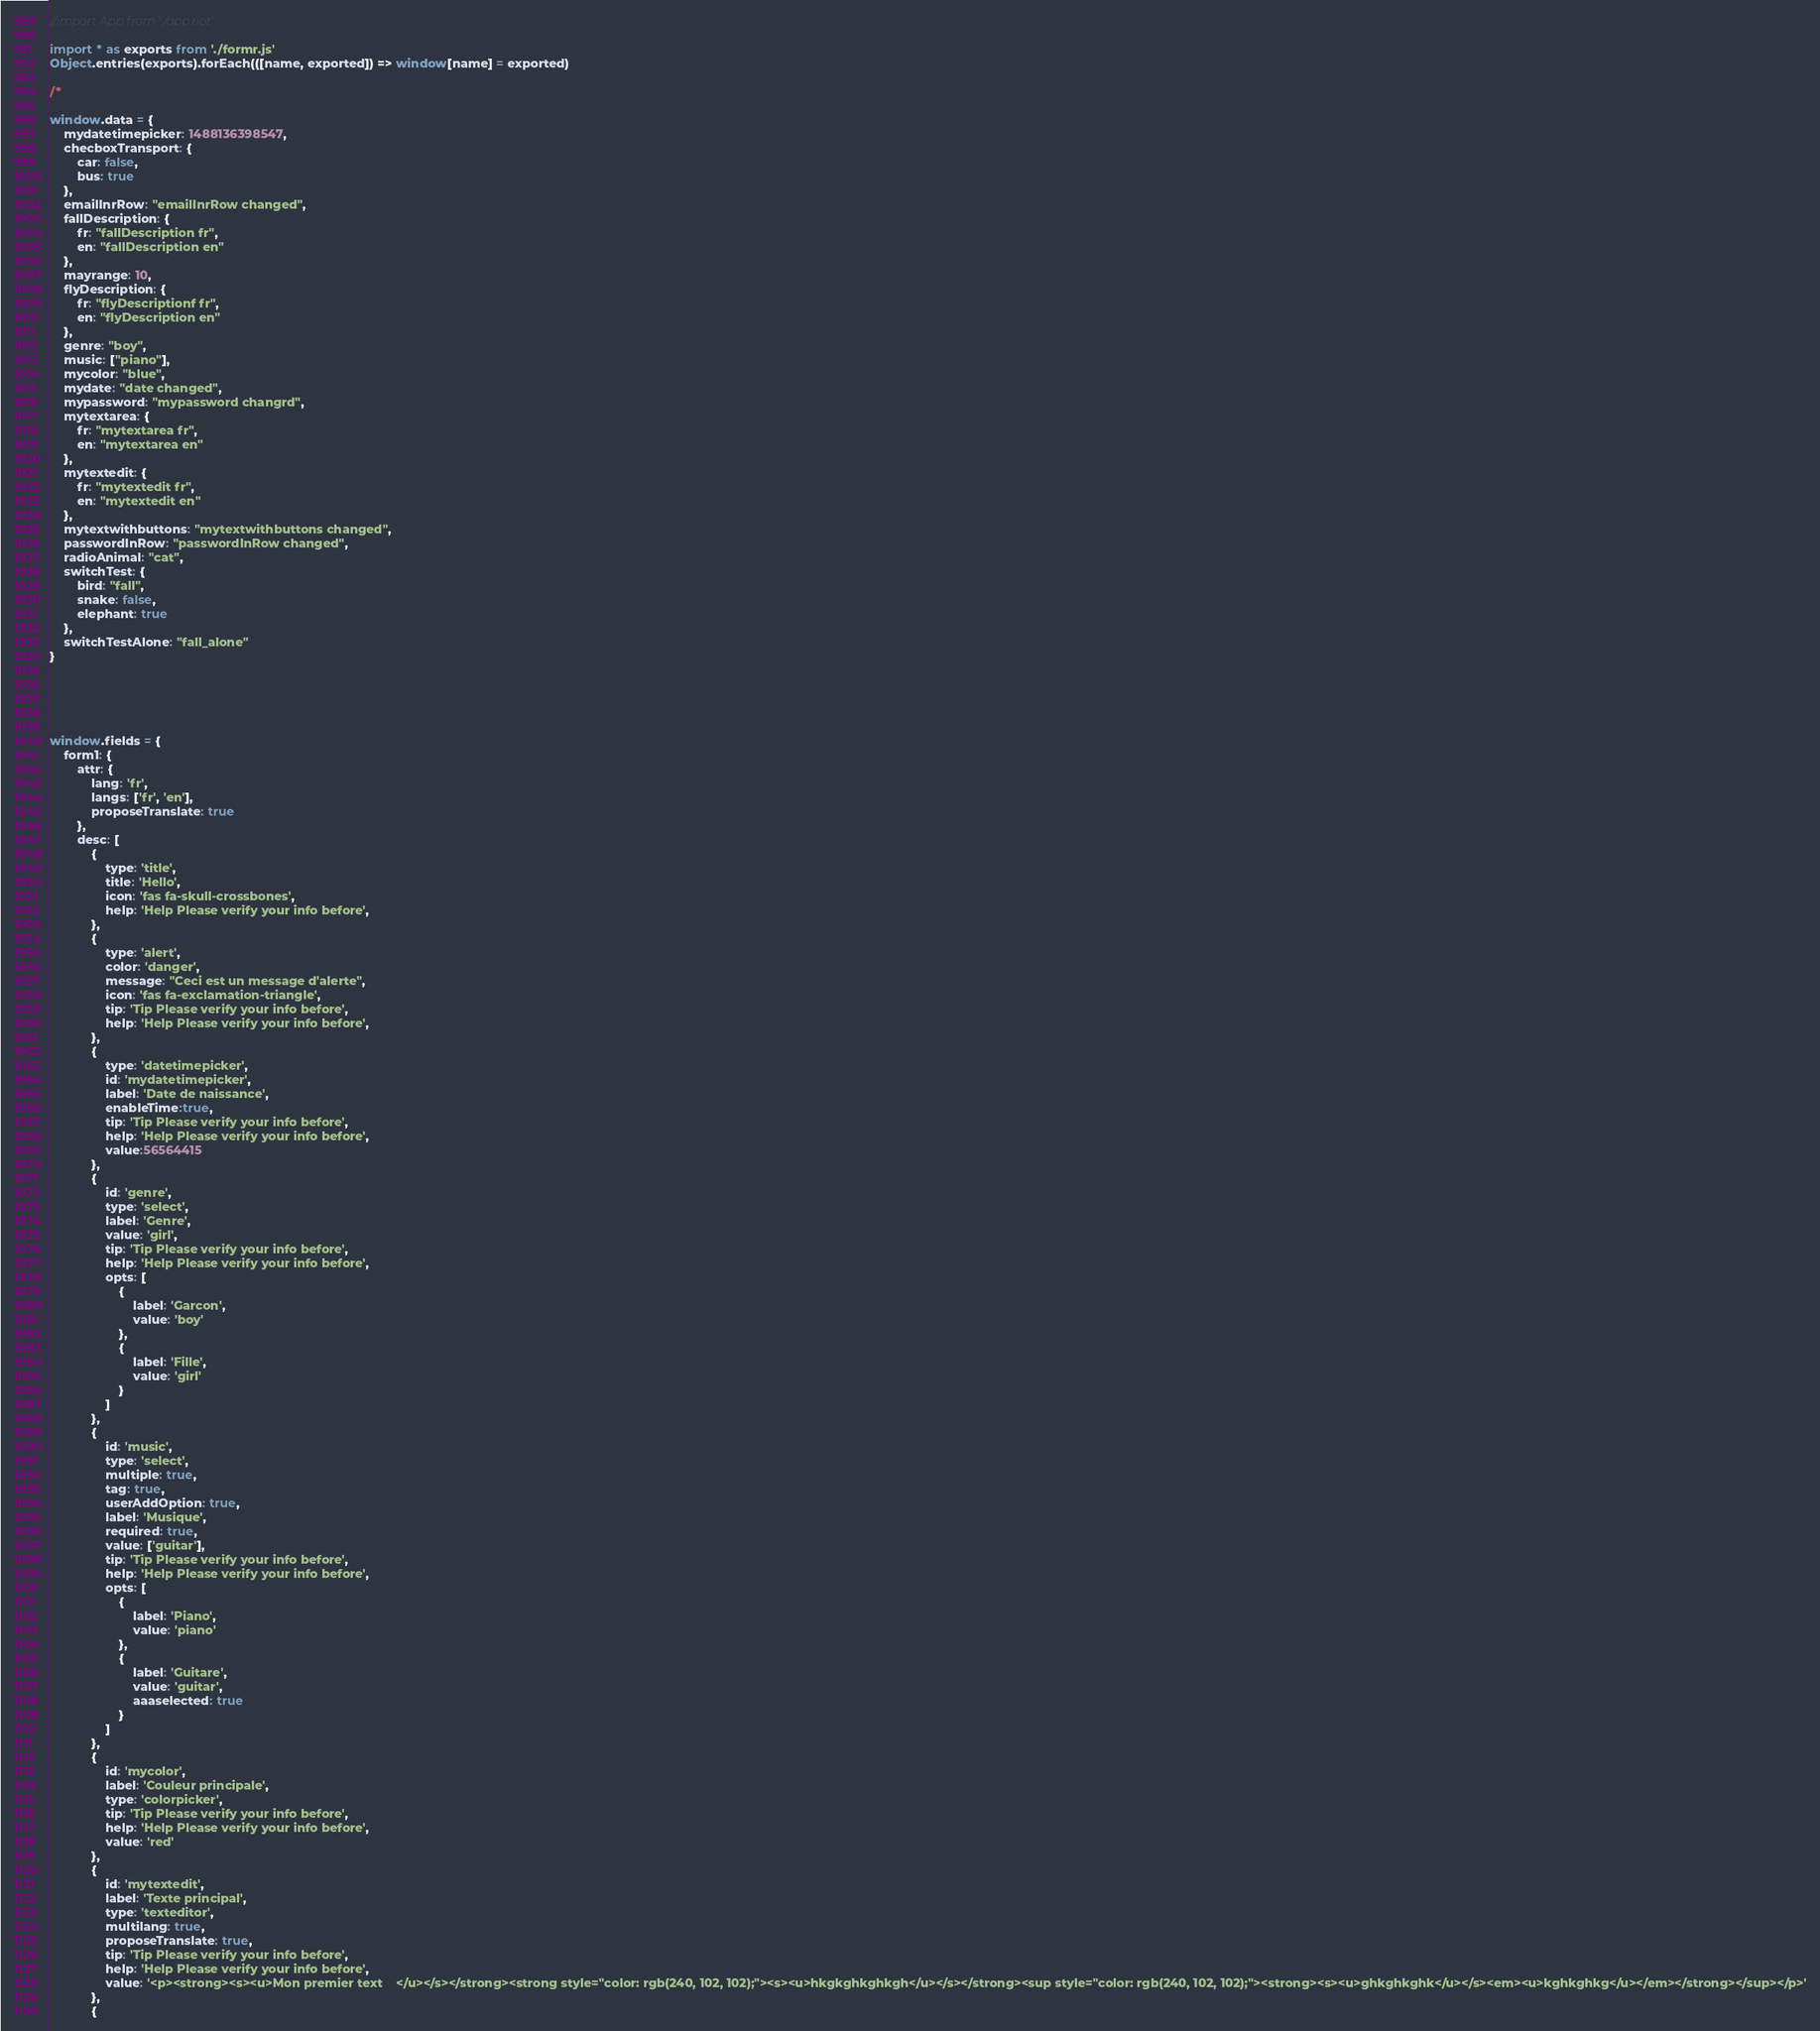<code> <loc_0><loc_0><loc_500><loc_500><_JavaScript_>//import App from './app.riot'

import * as exports from './formr.js'
Object.entries(exports).forEach(([name, exported]) => window[name] = exported)

/*

window.data = {
    mydatetimepicker: 1488136398547,
    checboxTransport: {
        car: false,
        bus: true
    },
    emailInrRow: "emailInrRow changed",
    fallDescription: {
        fr: "fallDescription fr",
        en: "fallDescription en"
    },
    mayrange: 10,
    flyDescription: {
        fr: "flyDescriptionf fr",
        en: "flyDescription en"
    },
    genre: "boy",
    music: ["piano"],
    mycolor: "blue",
    mydate: "date changed",
    mypassword: "mypassword changrd",
    mytextarea: {
        fr: "mytextarea fr",
        en: "mytextarea en"
    },
    mytextedit: {
        fr: "mytextedit fr",
        en: "mytextedit en"
    },
    mytextwithbuttons: "mytextwithbuttons changed",
    passwordInRow: "passwordInRow changed",
    radioAnimal: "cat",
    switchTest: {
        bird: "fall",
        snake: false,
        elephant: true
    },
    switchTestAlone: "fall_alone"
}





window.fields = {
    form1: {
        attr: {
            lang: 'fr',
            langs: ['fr', 'en'],
            proposeTranslate: true
        },
        desc: [
            {
                type: 'title',
                title: 'Hello',
                icon: 'fas fa-skull-crossbones',
                help: 'Help Please verify your info before',
            },
            {
                type: 'alert',
                color: 'danger',
                message: "Ceci est un message d'alerte",
                icon: 'fas fa-exclamation-triangle',
                tip: 'Tip Please verify your info before',
                help: 'Help Please verify your info before',
            },
            {
                type: 'datetimepicker',
                id: 'mydatetimepicker',
                label: 'Date de naissance',
                enableTime:true,
                tip: 'Tip Please verify your info before',
                help: 'Help Please verify your info before',
                value:56564415
            },
            {
                id: 'genre',
                type: 'select',
                label: 'Genre',
                value: 'girl',
                tip: 'Tip Please verify your info before',
                help: 'Help Please verify your info before',
                opts: [
                    {
                        label: 'Garcon',
                        value: 'boy'
                    },
                    {
                        label: 'Fille',
                        value: 'girl'
                    }
                ]
            },
            {
                id: 'music',
                type: 'select',
                multiple: true,
                tag: true,
                userAddOption: true,
                label: 'Musique',
                required: true,
                value: ['guitar'],
                tip: 'Tip Please verify your info before',
                help: 'Help Please verify your info before',
                opts: [
                    {
                        label: 'Piano',
                        value: 'piano'
                    },
                    {
                        label: 'Guitare',
                        value: 'guitar',
                        aaaselected: true
                    }
                ]
            },
            {
                id: 'mycolor',
                label: 'Couleur principale',
                type: 'colorpicker',
                tip: 'Tip Please verify your info before',
                help: 'Help Please verify your info before',
                value: 'red'
            },
            {
                id: 'mytextedit',
                label: 'Texte principal',
                type: 'texteditor',
                multilang: true,
                proposeTranslate: true,
                tip: 'Tip Please verify your info before',
                help: 'Help Please verify your info before',
                value: '<p><strong><s><u>Mon premier text    </u></s></strong><strong style="color: rgb(240, 102, 102);"><s><u>hkgkghkghkgh</u></s></strong><sup style="color: rgb(240, 102, 102);"><strong><s><u>ghkghkghk</u></s><em><u>kghkghkg</u></em></strong></sup></p>'
            },
            {</code> 